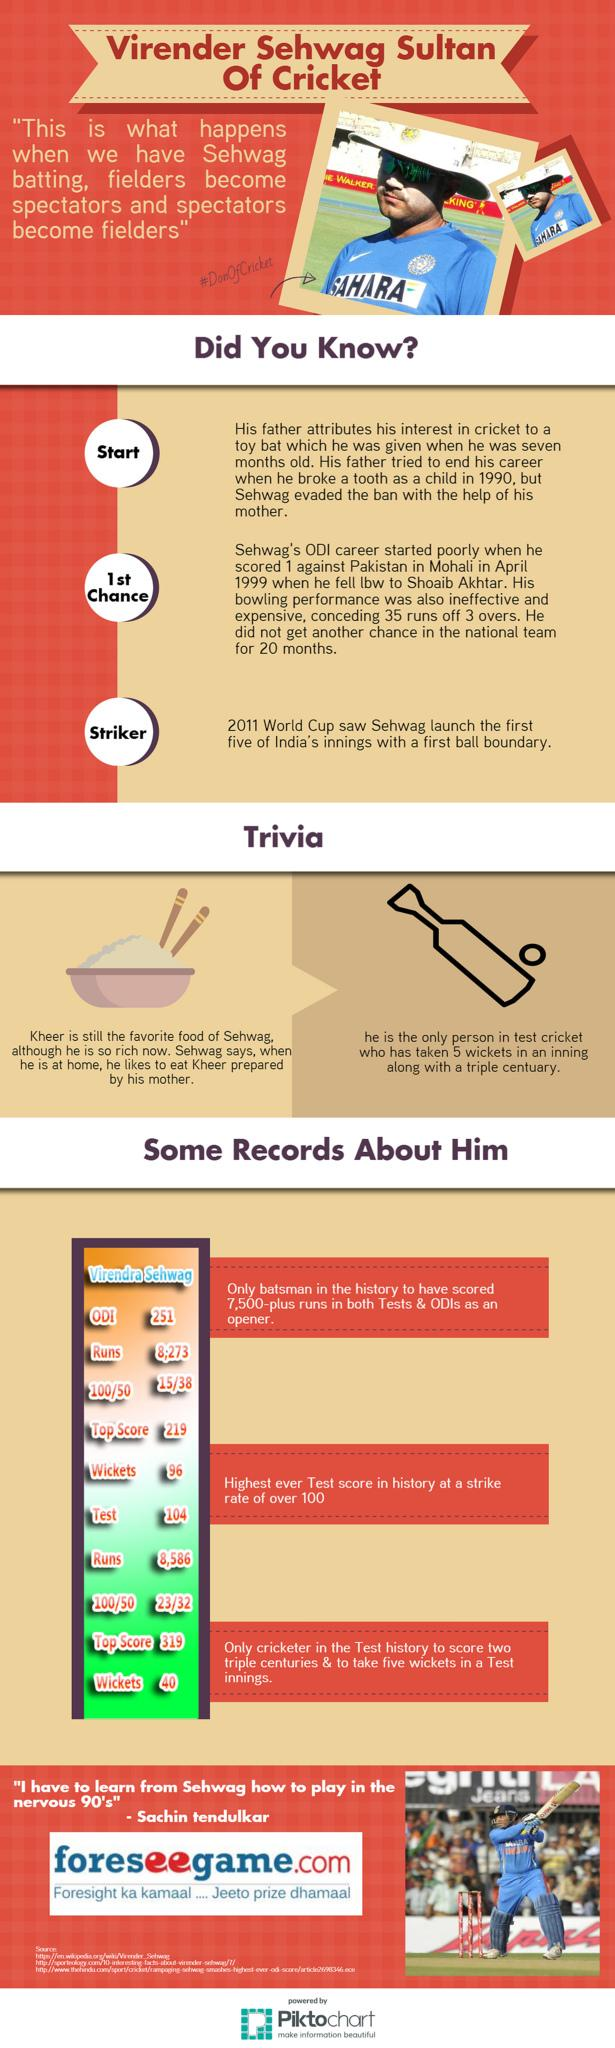Draw attention to some important aspects in this diagram. Sachin Sehwag scored a total of 23 centuries in his Test career, which is a remarkable achievement. Sehwag made a top score of 319 in a Test match, but I do not know if it was his highest score in an ODI or not. Sachin Sehwag took 96 wickets in One Day International matches, demonstrating his prowess as a bowler. The answer to the question "In which match did Sehwag make a top score of 219 - ODI or Test?" is ODI. Sachin Sehwag scored 15 hundreds in One Day International matches, a significant achievement that showcases his exceptional batting skills. 